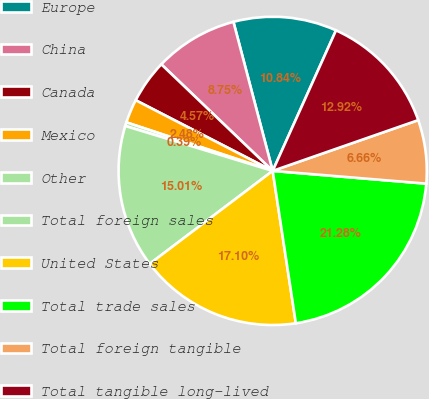Convert chart to OTSL. <chart><loc_0><loc_0><loc_500><loc_500><pie_chart><fcel>Europe<fcel>China<fcel>Canada<fcel>Mexico<fcel>Other<fcel>Total foreign sales<fcel>United States<fcel>Total trade sales<fcel>Total foreign tangible<fcel>Total tangible long-lived<nl><fcel>10.84%<fcel>8.75%<fcel>4.57%<fcel>2.48%<fcel>0.39%<fcel>15.01%<fcel>17.1%<fcel>21.28%<fcel>6.66%<fcel>12.92%<nl></chart> 